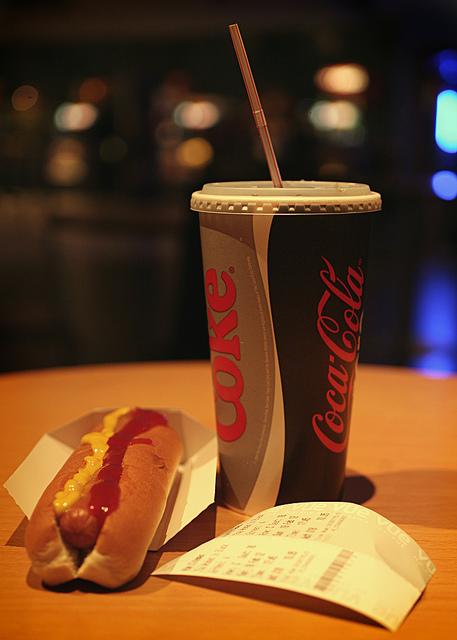Is there too much condiments on the hot dog?
Concise answer only. No. What brand of soda is served at this restaurant?
Keep it brief. Coca cola. How much would this cost?
Keep it brief. 3. Should someone with a nut allergy worry about the bread?
Write a very short answer. No. 